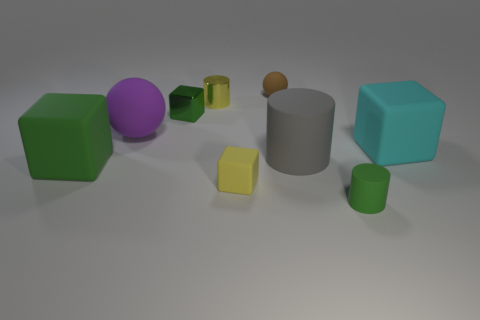Subtract all green blocks. How many were subtracted if there are1green blocks left? 1 Subtract all matte cubes. How many cubes are left? 1 Subtract all purple balls. How many balls are left? 1 Subtract all cylinders. How many objects are left? 6 Subtract 1 balls. How many balls are left? 1 Add 9 small purple matte cylinders. How many small purple matte cylinders exist? 9 Add 1 big purple things. How many objects exist? 10 Subtract 0 blue blocks. How many objects are left? 9 Subtract all blue balls. Subtract all green cylinders. How many balls are left? 2 Subtract all cyan cylinders. How many purple spheres are left? 1 